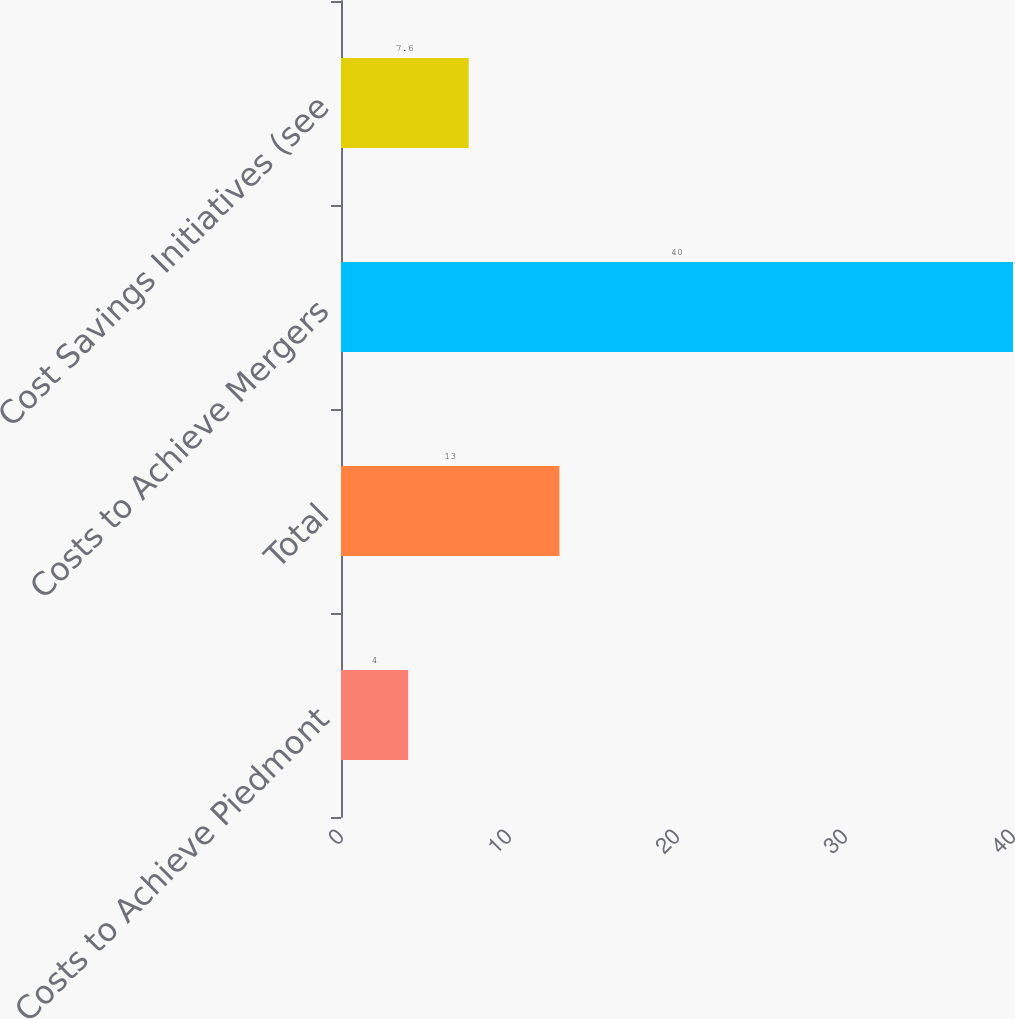Convert chart to OTSL. <chart><loc_0><loc_0><loc_500><loc_500><bar_chart><fcel>Costs to Achieve Piedmont<fcel>Total<fcel>Costs to Achieve Mergers<fcel>Cost Savings Initiatives (see<nl><fcel>4<fcel>13<fcel>40<fcel>7.6<nl></chart> 